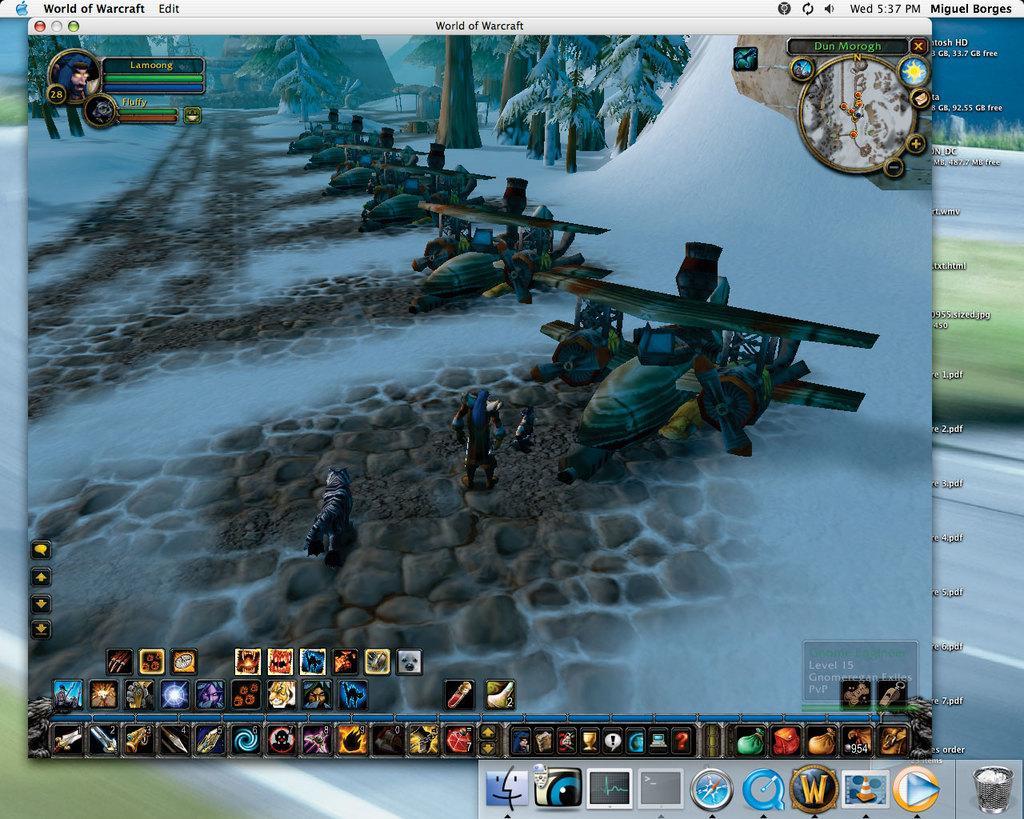Describe this image in one or two sentences. In this image we can see an animation of many aircrafts, trees, snow etc., in the image. There are many animated photos and logos at the bottom of the image. There is some text at the top of the image. 